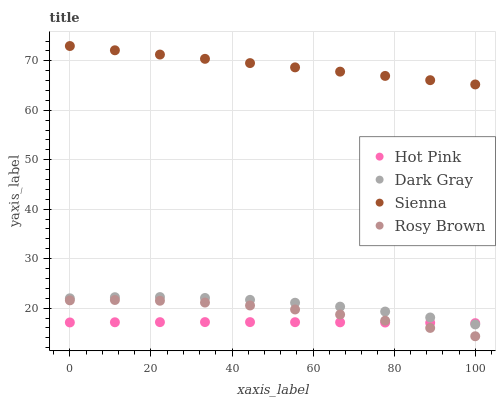Does Hot Pink have the minimum area under the curve?
Answer yes or no. Yes. Does Sienna have the maximum area under the curve?
Answer yes or no. Yes. Does Rosy Brown have the minimum area under the curve?
Answer yes or no. No. Does Rosy Brown have the maximum area under the curve?
Answer yes or no. No. Is Sienna the smoothest?
Answer yes or no. Yes. Is Rosy Brown the roughest?
Answer yes or no. Yes. Is Rosy Brown the smoothest?
Answer yes or no. No. Is Sienna the roughest?
Answer yes or no. No. Does Rosy Brown have the lowest value?
Answer yes or no. Yes. Does Sienna have the lowest value?
Answer yes or no. No. Does Sienna have the highest value?
Answer yes or no. Yes. Does Rosy Brown have the highest value?
Answer yes or no. No. Is Dark Gray less than Sienna?
Answer yes or no. Yes. Is Sienna greater than Hot Pink?
Answer yes or no. Yes. Does Dark Gray intersect Hot Pink?
Answer yes or no. Yes. Is Dark Gray less than Hot Pink?
Answer yes or no. No. Is Dark Gray greater than Hot Pink?
Answer yes or no. No. Does Dark Gray intersect Sienna?
Answer yes or no. No. 